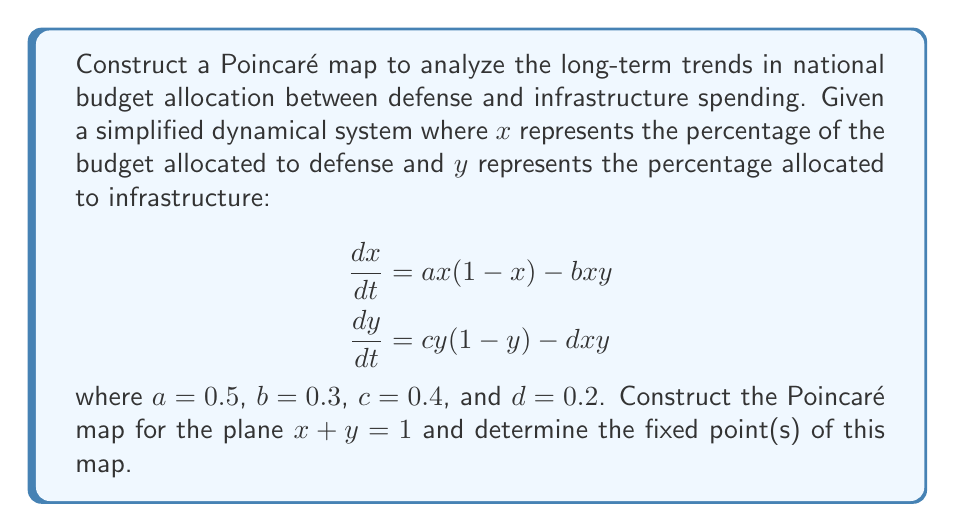Provide a solution to this math problem. To construct the Poincaré map and find its fixed points, we follow these steps:

1) First, we need to find the intersection of the flow with the plane $x+y=1$. This plane represents the constraint that the total budget allocation must sum to 100%.

2) We can parameterize this plane as:
   $x = t$, $y = 1-t$, where $0 \leq t \leq 1$

3) Substituting these into our dynamical system:

   $$\begin{align}
   \frac{dt}{dt} &= 0.5t(1-t) - 0.3t(1-t) = 0.2t(1-t) \\
   \frac{d(1-t)}{dt} &= 0.4(1-t)(1-(1-t)) - 0.2t(1-t) = 0.4t(1-t) - 0.2t(1-t) = 0.2t(1-t)
   \end{align}$$

4) The Poincaré map $P(t)$ is given by the solution to this system after one complete orbit. Due to the symmetry in these equations, we can see that the fixed points will occur where $\frac{dt}{dt} = 0$, which happens when $t=0$, $t=1$, or $t=0.5$.

5) $t=0$ represents 0% defense spending and 100% infrastructure spending, $t=1$ represents 100% defense spending and 0% infrastructure spending, and $t=0.5$ represents a 50-50 split.

6) To determine stability, we can look at the derivative of $\frac{dt}{dt}$ with respect to $t$:

   $$\frac{d}{dt}(0.2t(1-t)) = 0.2(1-2t)$$

7) At $t=0$ and $t=1$, this derivative is positive and negative respectively, indicating that these are unstable fixed points. At $t=0.5$, the derivative is 0, indicating a stable fixed point.

Therefore, the Poincaré map has three fixed points: (0,1), (1,0), and (0.5,0.5), with (0.5,0.5) being the only stable fixed point.
Answer: Fixed points: (0,1), (1,0), (0.5,0.5); (0.5,0.5) is stable. 